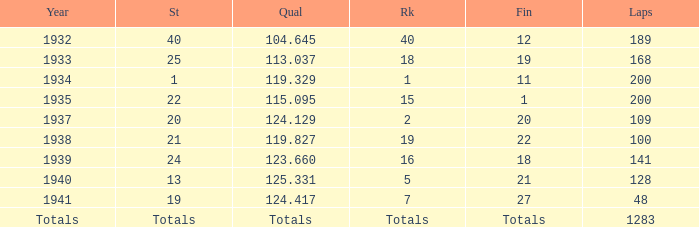What was the rank with the qual of 115.095? 15.0. 